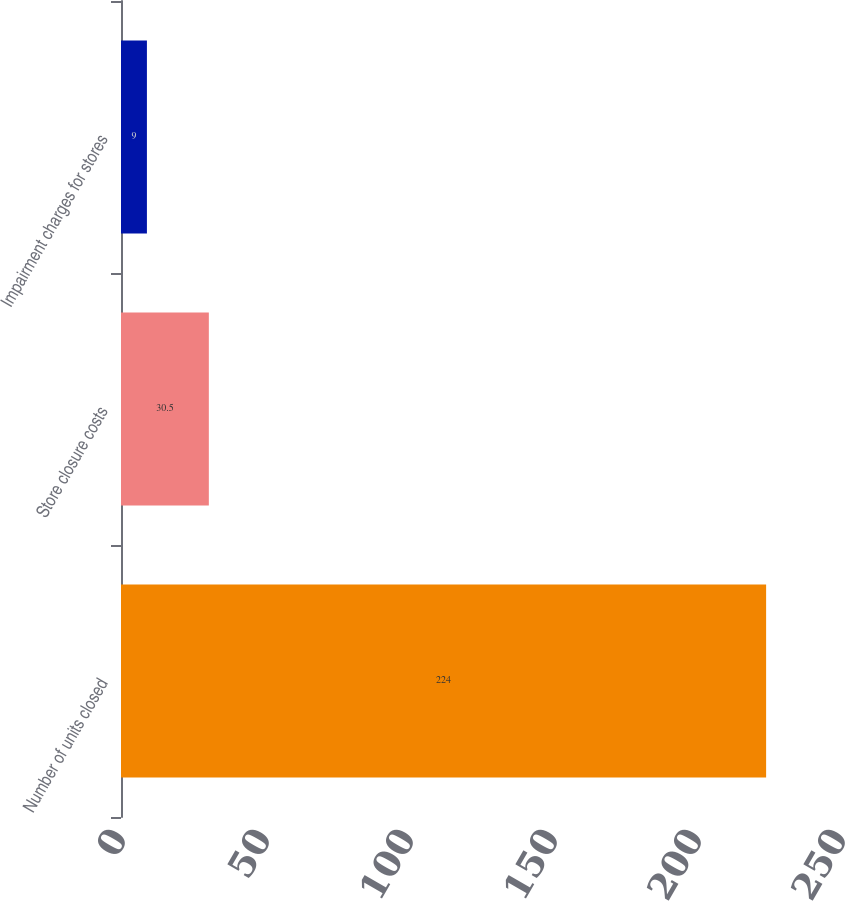Convert chart to OTSL. <chart><loc_0><loc_0><loc_500><loc_500><bar_chart><fcel>Number of units closed<fcel>Store closure costs<fcel>Impairment charges for stores<nl><fcel>224<fcel>30.5<fcel>9<nl></chart> 